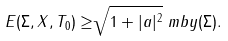<formula> <loc_0><loc_0><loc_500><loc_500>E ( \Sigma , X , T _ { 0 } ) \geq & \sqrt { 1 + | a | ^ { 2 } } \ m b y ( \Sigma ) .</formula> 